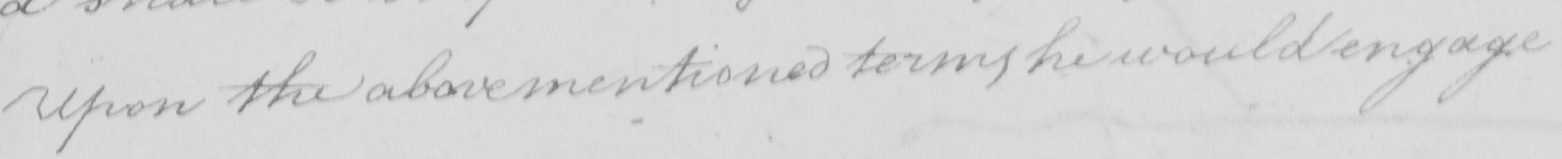Please transcribe the handwritten text in this image. Upon the abovementioned terms he would engage 